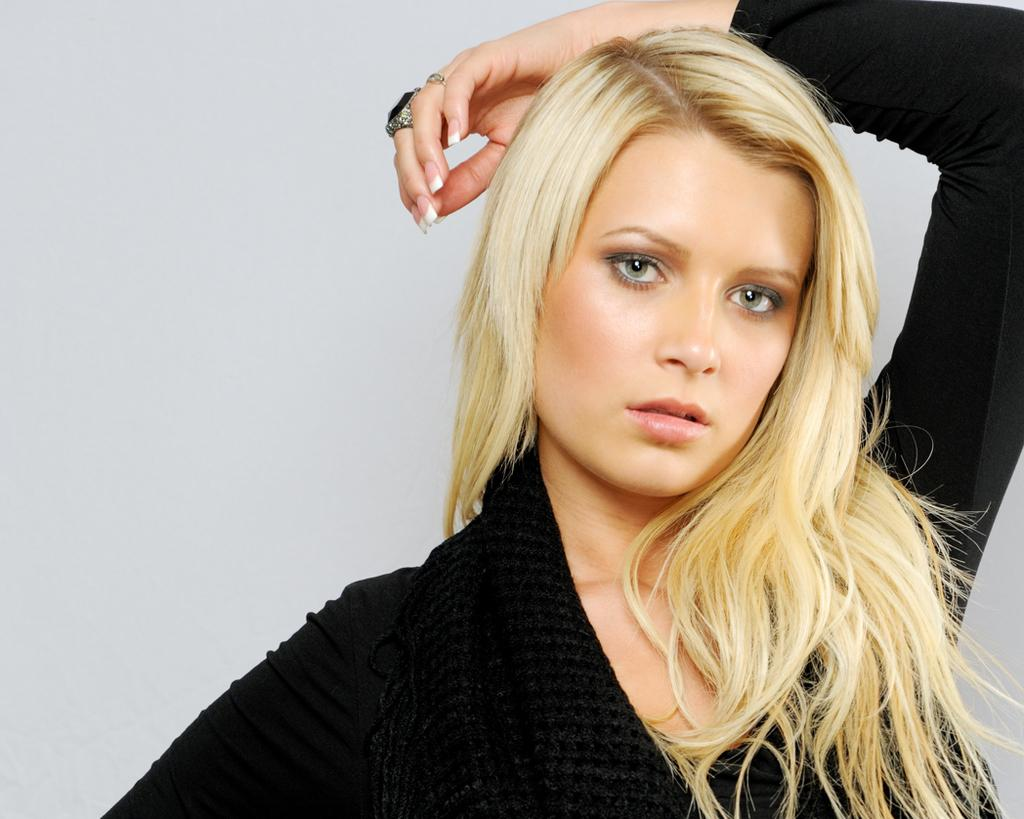Who is the main subject in the image? There is a lady in the image. What is the lady wearing? The lady is wearing a black dress. Are there any accessories visible on the lady? Yes, the lady has a black ring. Can you describe the lady's hairstyle? The lady has short hair. What type of baseball is the lady holding in the image? There is no baseball present in the image. What kind of jewel can be seen in the lady's hair? There is no jewel visible in the lady's hair; she has short hair. Can you describe the ocean view in the background of the image? There is no ocean or background visible in the image; it only features the lady. 